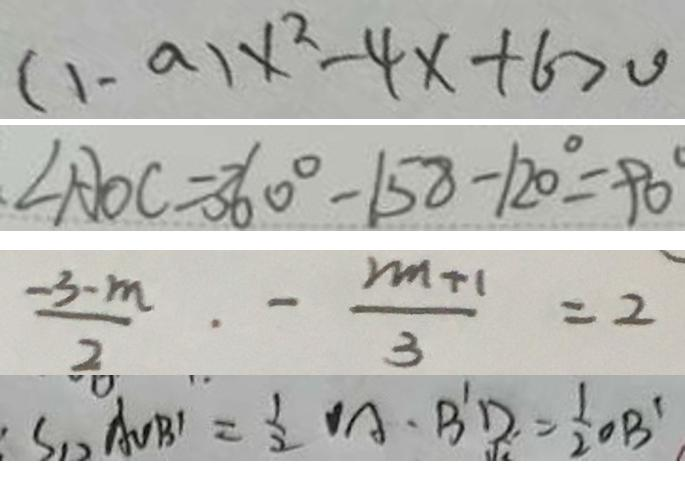Convert formula to latex. <formula><loc_0><loc_0><loc_500><loc_500>( 1 - a ) x ^ { 2 } - 4 x + 6 > 0 
 \angle A O C = 3 6 0 ^ { \circ } - 1 5 8 - 1 2 0 ^ { \circ } = 9 0 ^ { \circ } 
 \frac { - 3 - m } { 2 } \cdot - \frac { 2 m + 1 } { 3 } = 2 
 S _ { \Delta A O B ^ { \prime } } = \frac { 1 } { 2 } O A \cdot B ^ { \prime } D = \frac { 1 } { 2 } O B ^ { \prime }</formula> 